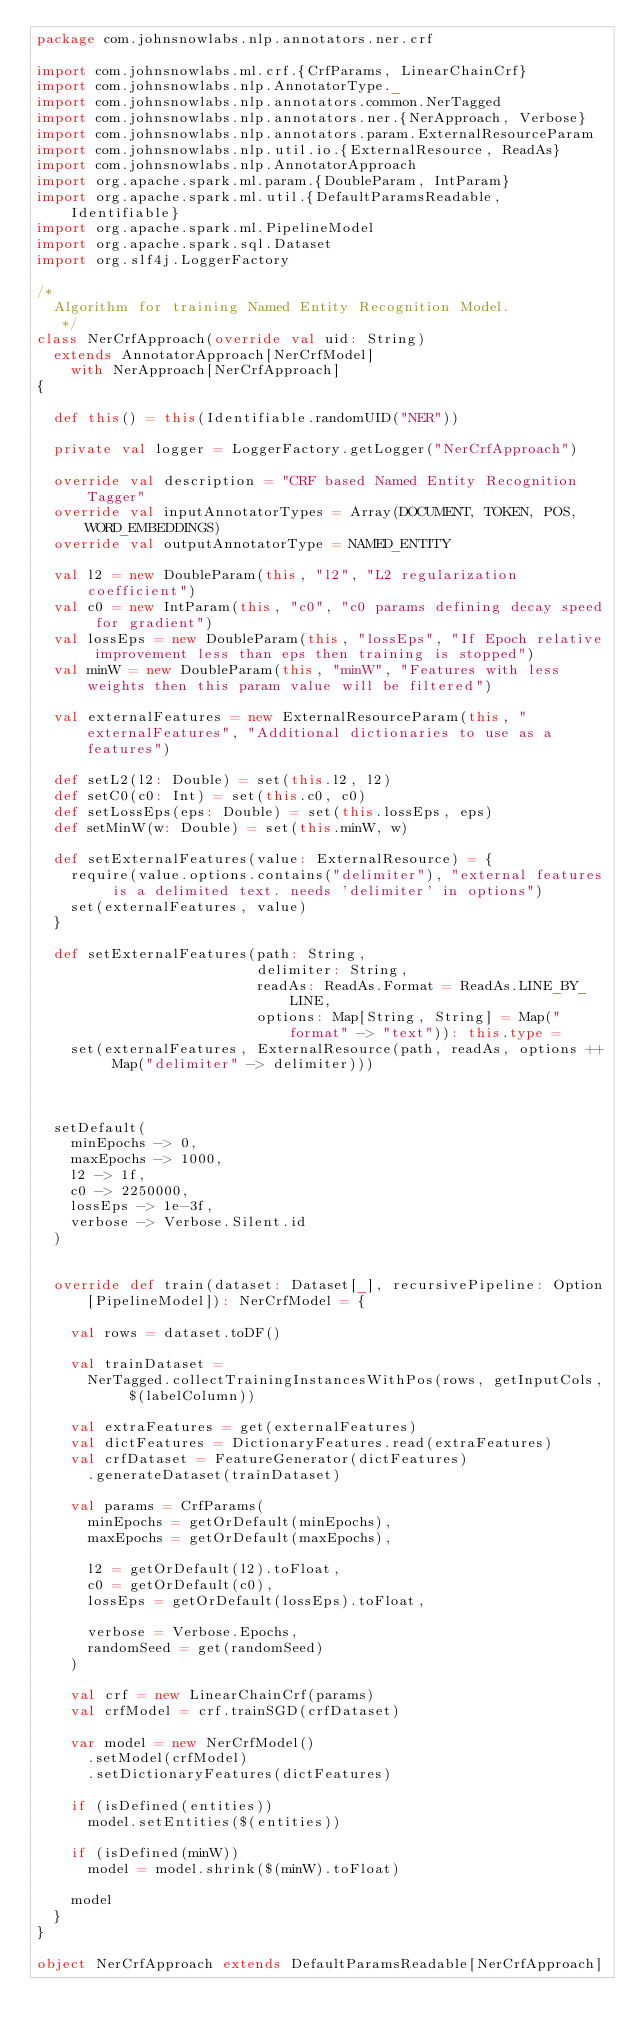<code> <loc_0><loc_0><loc_500><loc_500><_Scala_>package com.johnsnowlabs.nlp.annotators.ner.crf

import com.johnsnowlabs.ml.crf.{CrfParams, LinearChainCrf}
import com.johnsnowlabs.nlp.AnnotatorType._
import com.johnsnowlabs.nlp.annotators.common.NerTagged
import com.johnsnowlabs.nlp.annotators.ner.{NerApproach, Verbose}
import com.johnsnowlabs.nlp.annotators.param.ExternalResourceParam
import com.johnsnowlabs.nlp.util.io.{ExternalResource, ReadAs}
import com.johnsnowlabs.nlp.AnnotatorApproach
import org.apache.spark.ml.param.{DoubleParam, IntParam}
import org.apache.spark.ml.util.{DefaultParamsReadable, Identifiable}
import org.apache.spark.ml.PipelineModel
import org.apache.spark.sql.Dataset
import org.slf4j.LoggerFactory

/*
  Algorithm for training Named Entity Recognition Model.
   */
class NerCrfApproach(override val uid: String)
  extends AnnotatorApproach[NerCrfModel]
    with NerApproach[NerCrfApproach]
{

  def this() = this(Identifiable.randomUID("NER"))

  private val logger = LoggerFactory.getLogger("NerCrfApproach")

  override val description = "CRF based Named Entity Recognition Tagger"
  override val inputAnnotatorTypes = Array(DOCUMENT, TOKEN, POS, WORD_EMBEDDINGS)
  override val outputAnnotatorType = NAMED_ENTITY

  val l2 = new DoubleParam(this, "l2", "L2 regularization coefficient")
  val c0 = new IntParam(this, "c0", "c0 params defining decay speed for gradient")
  val lossEps = new DoubleParam(this, "lossEps", "If Epoch relative improvement less than eps then training is stopped")
  val minW = new DoubleParam(this, "minW", "Features with less weights then this param value will be filtered")

  val externalFeatures = new ExternalResourceParam(this, "externalFeatures", "Additional dictionaries to use as a features")

  def setL2(l2: Double) = set(this.l2, l2)
  def setC0(c0: Int) = set(this.c0, c0)
  def setLossEps(eps: Double) = set(this.lossEps, eps)
  def setMinW(w: Double) = set(this.minW, w)

  def setExternalFeatures(value: ExternalResource) = {
    require(value.options.contains("delimiter"), "external features is a delimited text. needs 'delimiter' in options")
    set(externalFeatures, value)
  }

  def setExternalFeatures(path: String,
                          delimiter: String,
                          readAs: ReadAs.Format = ReadAs.LINE_BY_LINE,
                          options: Map[String, String] = Map("format" -> "text")): this.type =
    set(externalFeatures, ExternalResource(path, readAs, options ++ Map("delimiter" -> delimiter)))



  setDefault(
    minEpochs -> 0,
    maxEpochs -> 1000,
    l2 -> 1f,
    c0 -> 2250000,
    lossEps -> 1e-3f,
    verbose -> Verbose.Silent.id
  )


  override def train(dataset: Dataset[_], recursivePipeline: Option[PipelineModel]): NerCrfModel = {

    val rows = dataset.toDF()

    val trainDataset =
      NerTagged.collectTrainingInstancesWithPos(rows, getInputCols, $(labelColumn))

    val extraFeatures = get(externalFeatures)
    val dictFeatures = DictionaryFeatures.read(extraFeatures)
    val crfDataset = FeatureGenerator(dictFeatures)
      .generateDataset(trainDataset)

    val params = CrfParams(
      minEpochs = getOrDefault(minEpochs),
      maxEpochs = getOrDefault(maxEpochs),

      l2 = getOrDefault(l2).toFloat,
      c0 = getOrDefault(c0),
      lossEps = getOrDefault(lossEps).toFloat,

      verbose = Verbose.Epochs,
      randomSeed = get(randomSeed)
    )

    val crf = new LinearChainCrf(params)
    val crfModel = crf.trainSGD(crfDataset)

    var model = new NerCrfModel()
      .setModel(crfModel)
      .setDictionaryFeatures(dictFeatures)

    if (isDefined(entities))
      model.setEntities($(entities))

    if (isDefined(minW))
      model = model.shrink($(minW).toFloat)

    model
  }
}

object NerCrfApproach extends DefaultParamsReadable[NerCrfApproach]</code> 